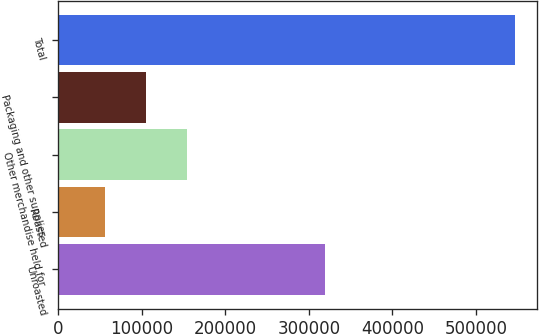Convert chart to OTSL. <chart><loc_0><loc_0><loc_500><loc_500><bar_chart><fcel>Unroasted<fcel>Roasted<fcel>Other merchandise held for<fcel>Packaging and other supplies<fcel>Total<nl><fcel>319745<fcel>56231<fcel>154245<fcel>105238<fcel>546299<nl></chart> 